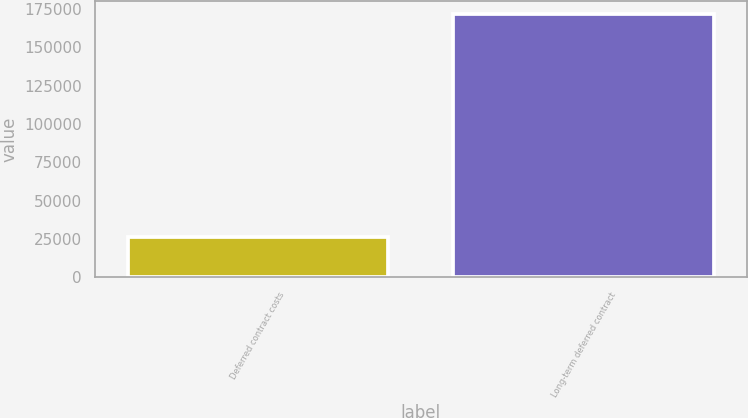Convert chart. <chart><loc_0><loc_0><loc_500><loc_500><bar_chart><fcel>Deferred contract costs<fcel>Long-term deferred contract<nl><fcel>26403<fcel>171865<nl></chart> 